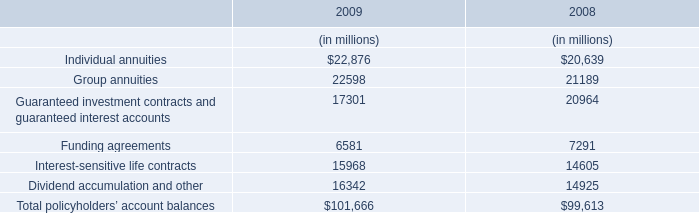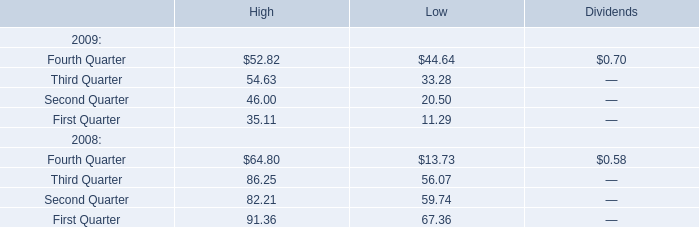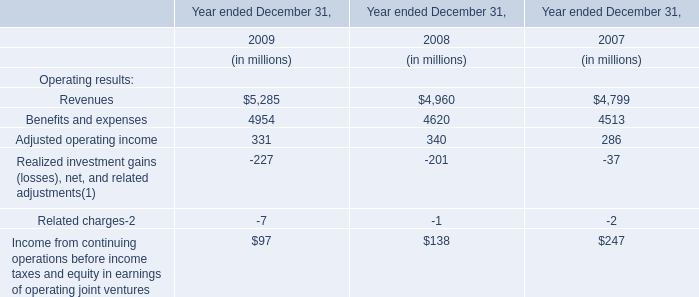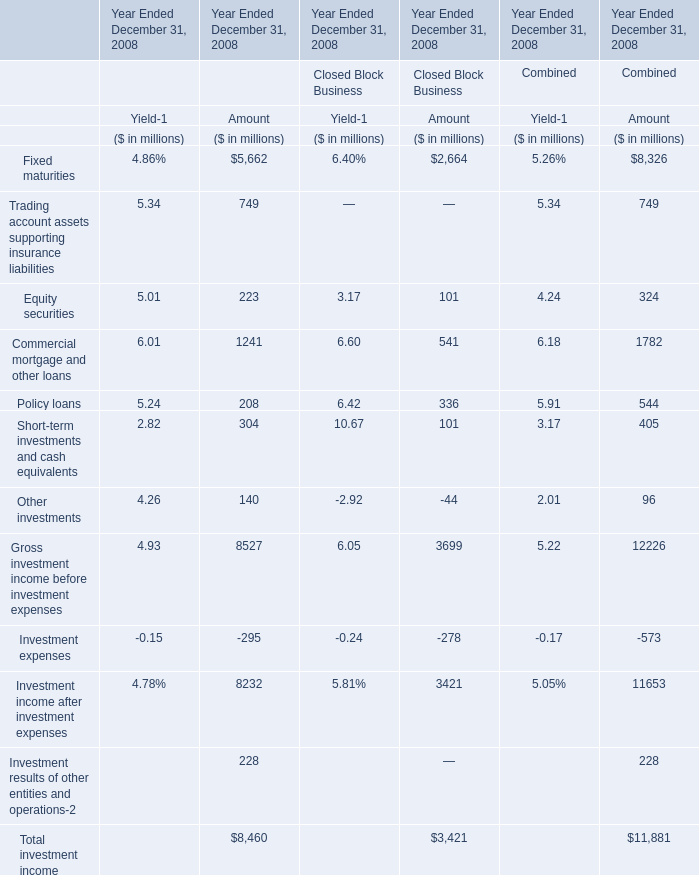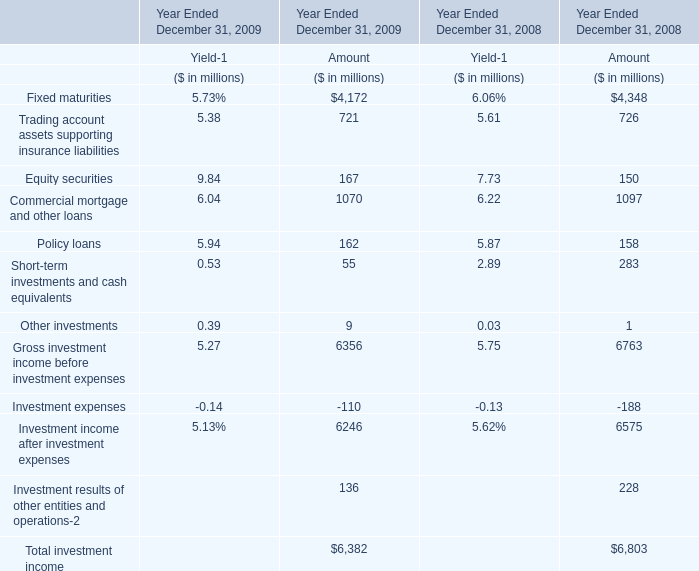What is the sum of Equity securities, Policy loans and Other investments for Amount in 2009? ? (in million) 
Computations: ((167 + 162) + 9)
Answer: 338.0. 